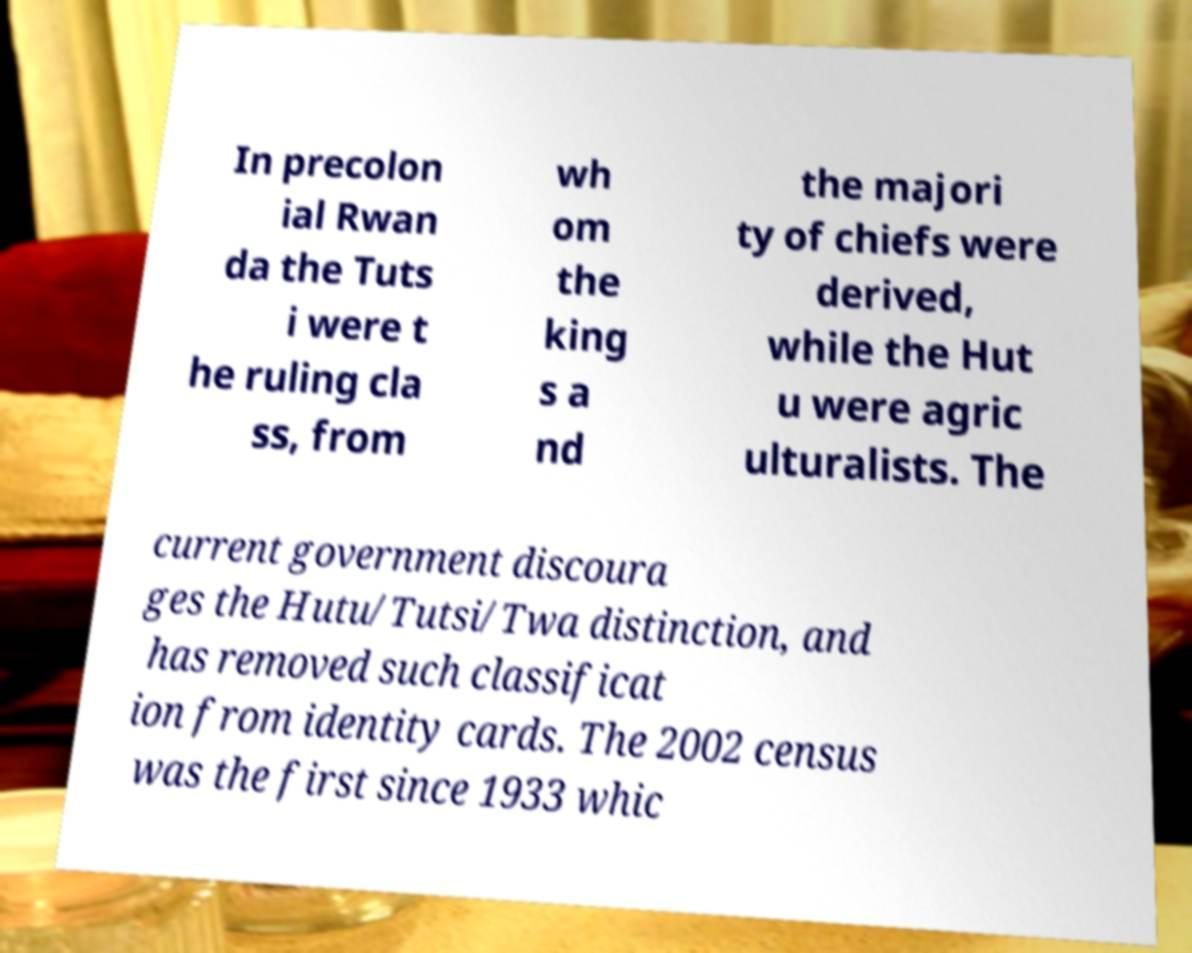Please identify and transcribe the text found in this image. In precolon ial Rwan da the Tuts i were t he ruling cla ss, from wh om the king s a nd the majori ty of chiefs were derived, while the Hut u were agric ulturalists. The current government discoura ges the Hutu/Tutsi/Twa distinction, and has removed such classificat ion from identity cards. The 2002 census was the first since 1933 whic 